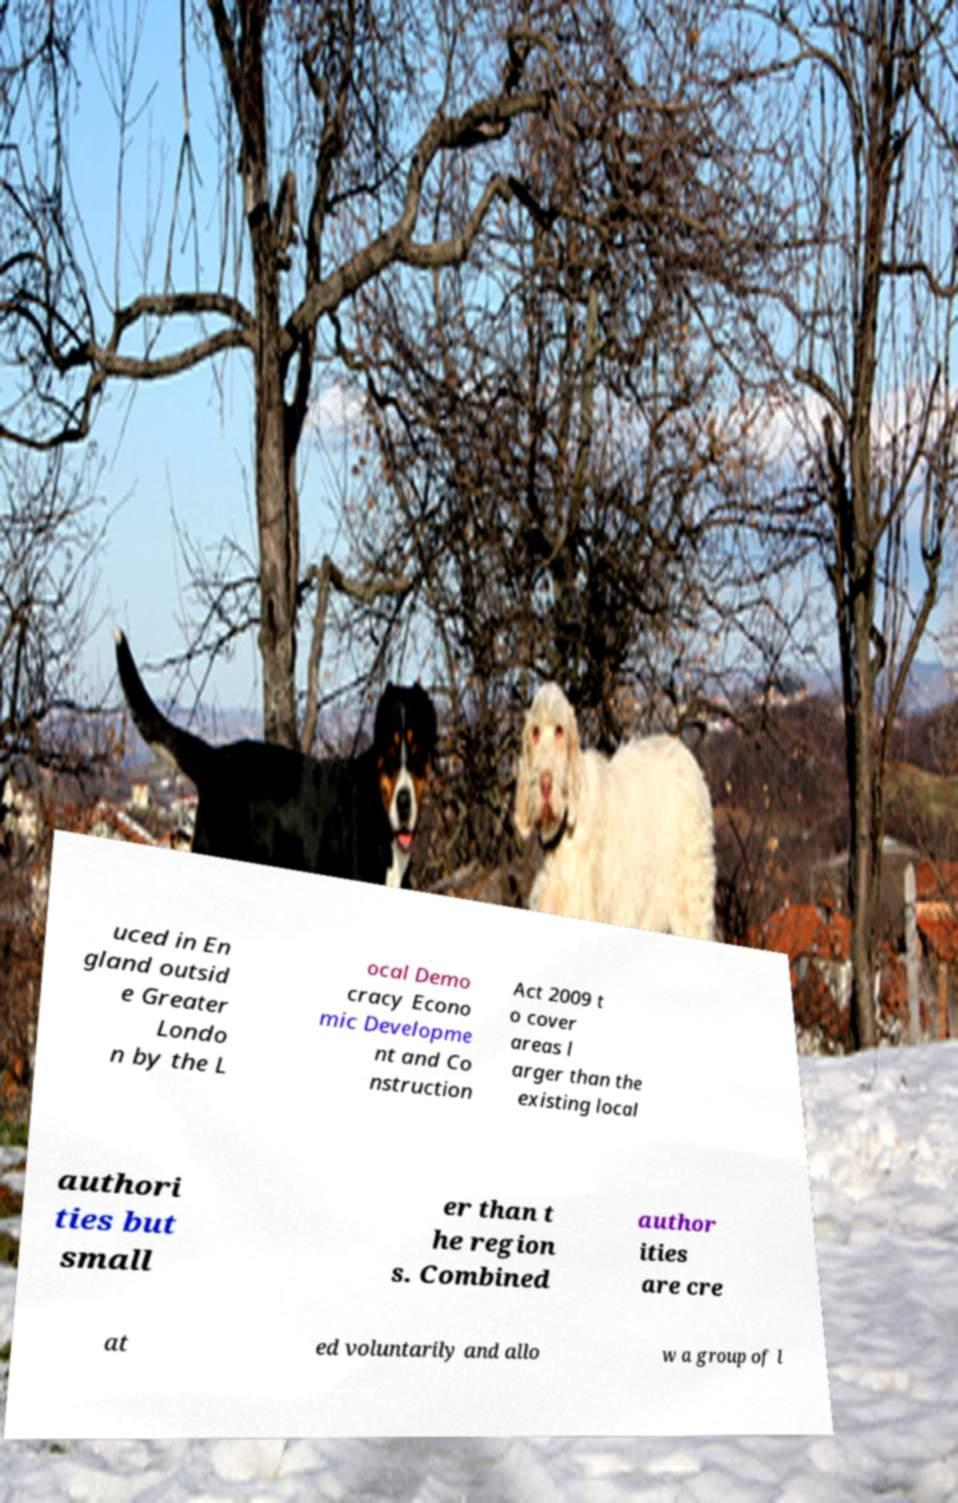I need the written content from this picture converted into text. Can you do that? uced in En gland outsid e Greater Londo n by the L ocal Demo cracy Econo mic Developme nt and Co nstruction Act 2009 t o cover areas l arger than the existing local authori ties but small er than t he region s. Combined author ities are cre at ed voluntarily and allo w a group of l 